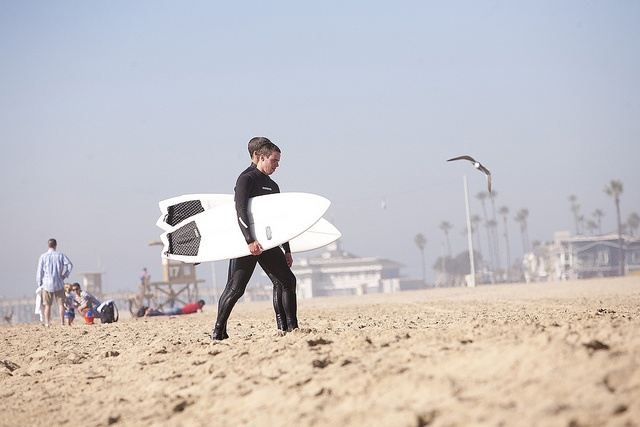Describe the objects in this image and their specific colors. I can see surfboard in darkgray, white, gray, and black tones, people in darkgray, black, gray, lightgray, and brown tones, surfboard in darkgray, white, black, and gray tones, people in darkgray, lavender, and gray tones, and people in darkgray, gray, and lightgray tones in this image. 